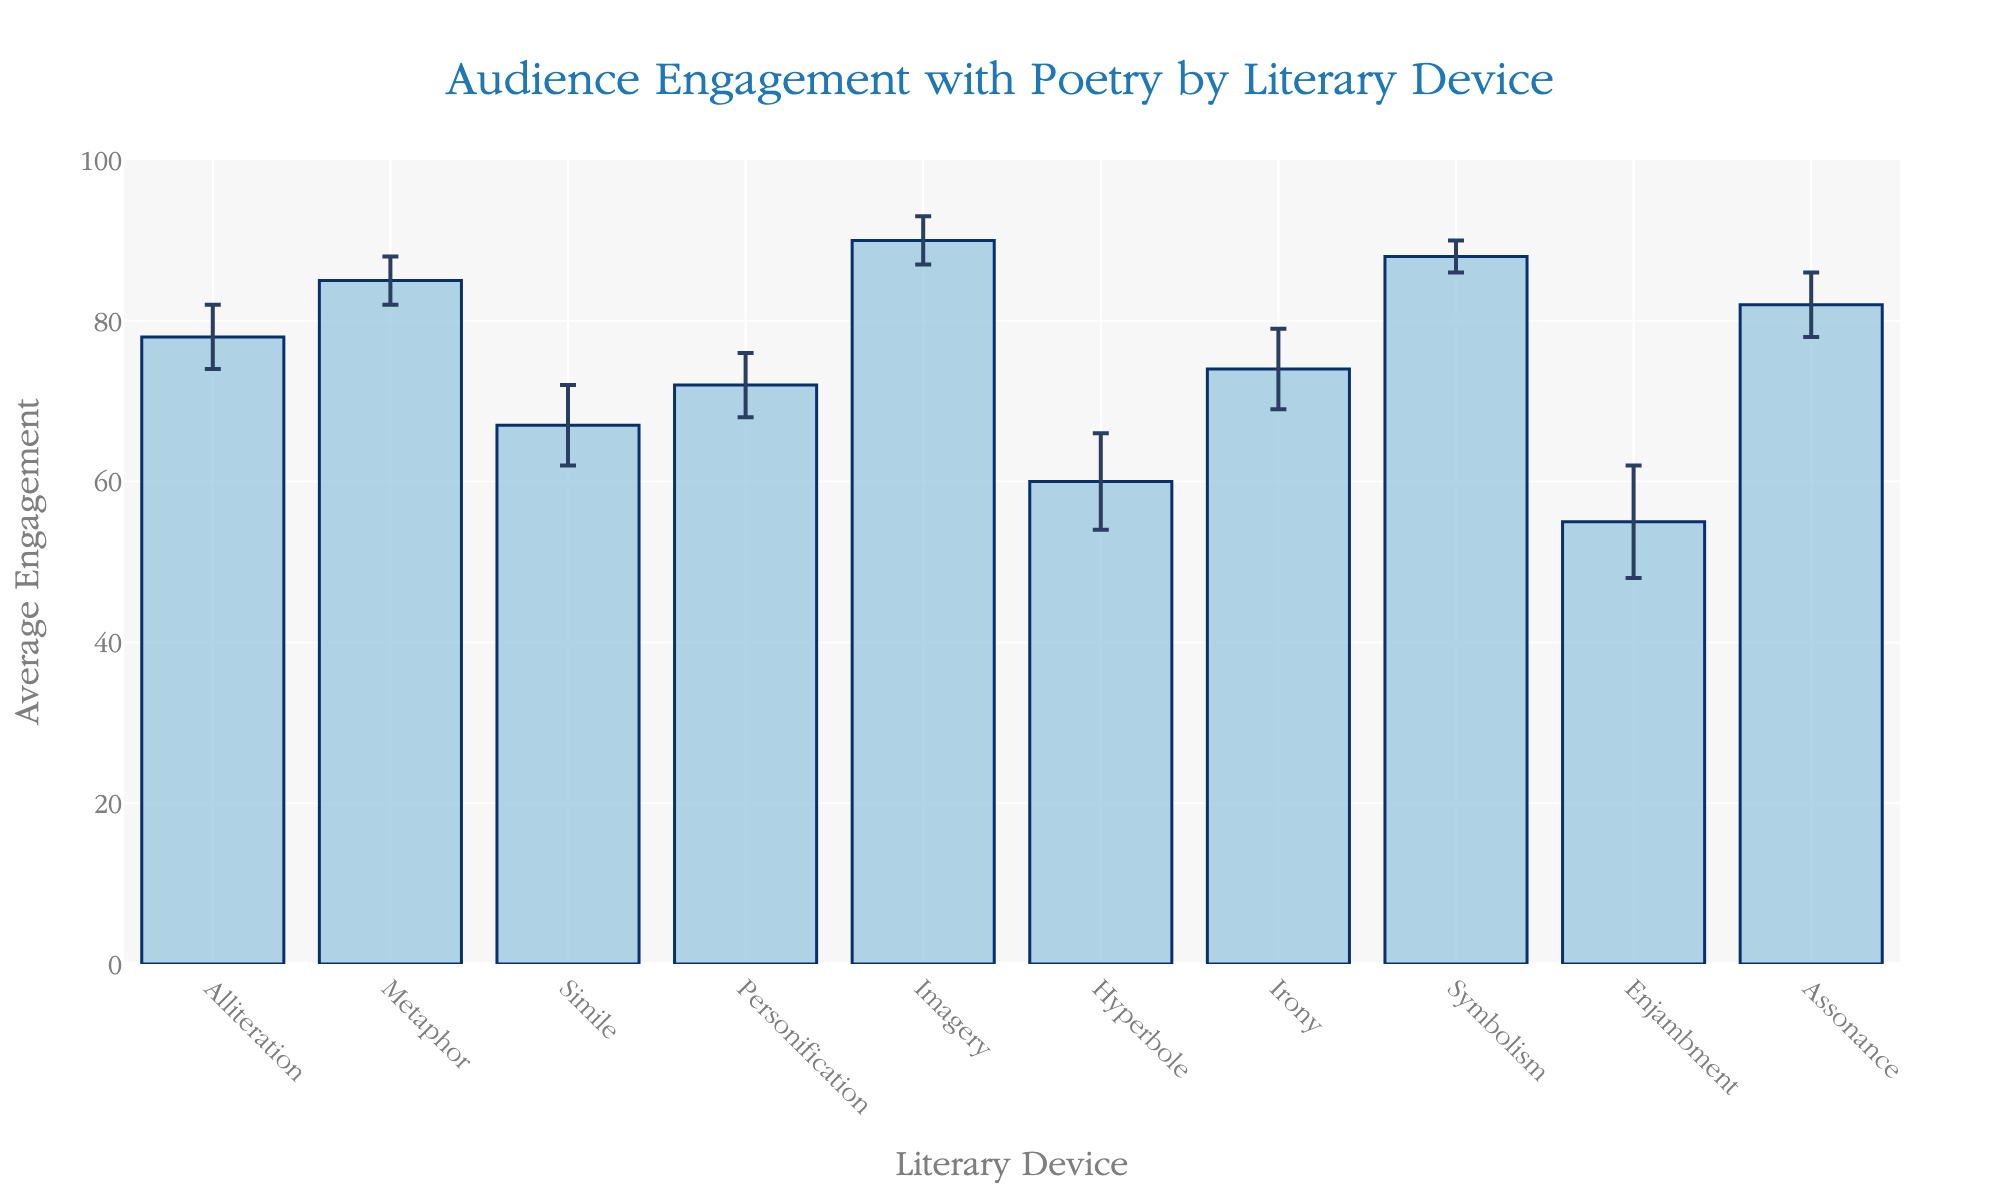What is the title of the figure? The title is positioned at the top center of the figure and reads clearly.
Answer: Audience Engagement with Poetry by Literary Device How many literary devices are shown in the figure? Counting the number of bars in the bar chart gives the total number of literary devices.
Answer: 10 Which literary device has the highest average engagement? By looking at the height of each bar, the tallest one corresponds to the highest average engagement.
Answer: Imagery What is the average engagement for the literary device 'Simile'? Locate the 'Simile' bar, and read its height.
Answer: 67 Which literary device has the largest error bar? Check each bar's error bar and identify the one that extends the furthest.
Answer: Enjambment Compare the average engagement of 'Metaphor' and 'Irony'. Which one is higher, and by how much? Metaphor has an average engagement of 85, while Irony has 74. Subtract to find the difference.
Answer: Metaphor is higher by 11 What is the mean average engagement across all literary devices? Sum the average engagement values for all literary devices and divide by the number of devices. (78+85+67+72+90+60+74+88+55+82)/10 = 751/10 = 75.1
Answer: 75.1 Which literary device shows the lowest average engagement? Identify the bar with the least height to find the lowest average engagement.
Answer: Enjambment What is the range of average engagement values shown in the figure? Subtract the lowest average engagement (Enjambment, 55) from the highest (Imagery, 90). 90-55 = 35
Answer: 35 How does the average engagement of 'Hyperbole' compare with its standard deviation? Locate 'Hyperbole' bar, noting its average engagement and the length of the error bar representing the standard deviation (6). Compare these two values.
Answer: 60 (engagement) is 10 times 6 (standard deviation) 